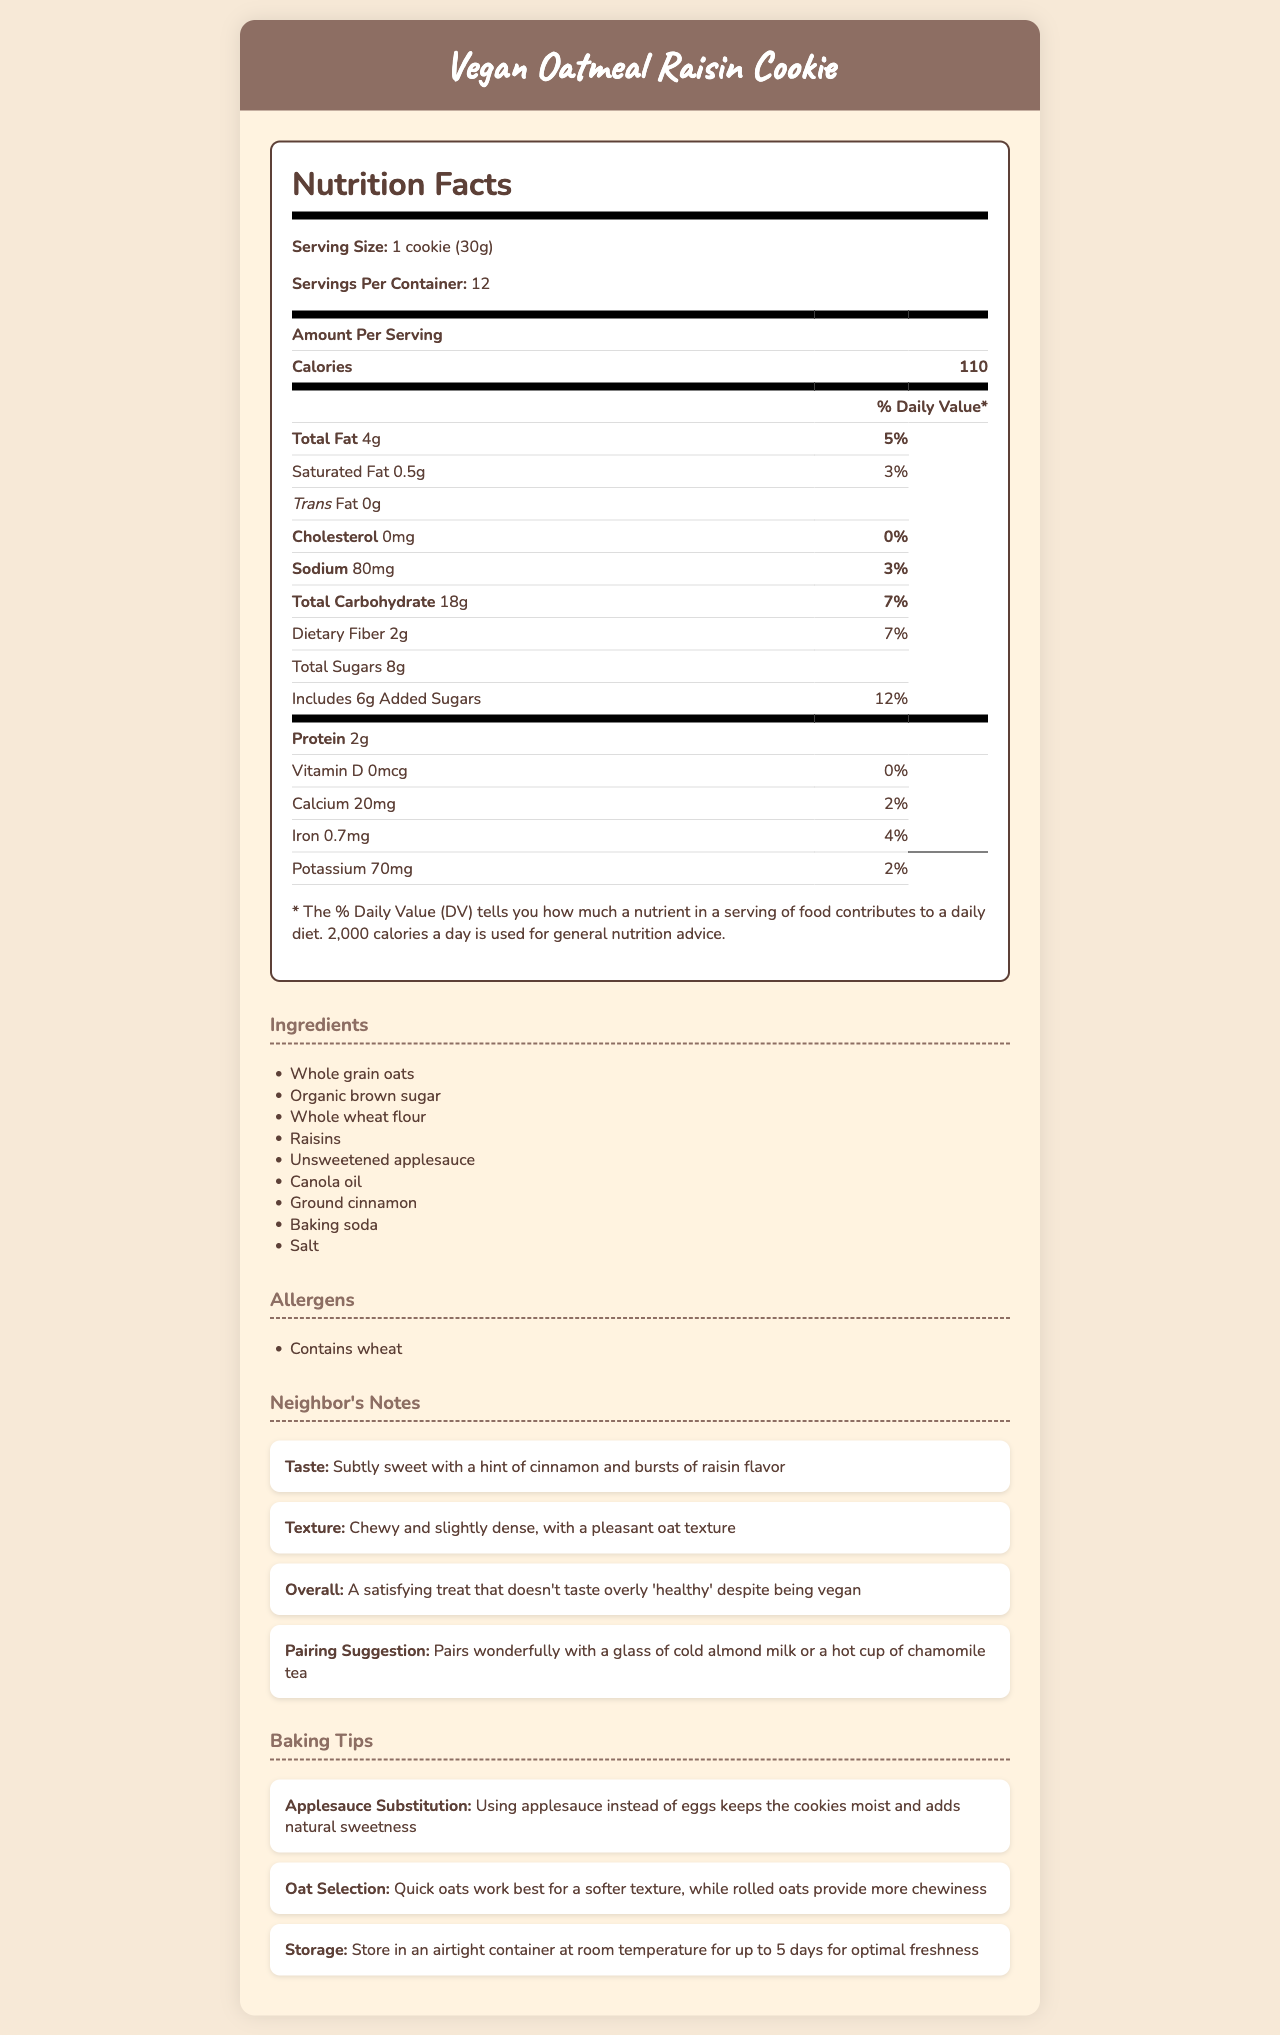what is the serving size of the vegan oatmeal raisin cookie? The serving size is specified at the beginning of the Nutrition Facts section as "1 cookie (30g)".
Answer: 1 cookie (30g) how many calories does one cookie have? The number of calories per serving is indicated in the Amount Per Serving section as "Calories: 110".
Answer: 110 how much total fat is in one serving of the cookie? Under the Total Fat section of the Nutrition Facts, it says "Total Fat 4g".
Answer: 4g what is the daily value percentage for dietary fiber? The daily value percentage for dietary fiber is listed as "7%" in the Total Carbohydrate section of the Nutrition Facts.
Answer: 7% what are the main ingredients of the cookie? The ingredients section lists all the main ingredients used in the cookie.
Answer: Whole grain oats, Organic brown sugar, Whole wheat flour, Raisins, Unsweetened applesauce, Canola oil, Ground cinnamon, Baking soda, Salt what allergens are in this cookie? The allergens section clearly mentions "Contains wheat".
Answer: Contains wheat what is the main advantage of using applesauce instead of eggs? The baking tips mention that using applesauce as a substitute keeps the cookies moist and adds natural sweetness.
Answer: Keeps the cookies moist and adds natural sweetness how many servings per container? The servings per container are mentioned at the beginning of the Nutrition Facts as "Servings Per Container: 12".
Answer: 12 which ingredient provides the cinnamon flavor in the cookie? The ingredient responsible for the cinnamon flavor is ground cinnamon, as listed in the Ingredients section.
Answer: Ground cinnamon what is the overall impression of the cookie according to the neighbor's notes? The Neighbor's Notes section gives an overall impression of the cookie as "A satisfying treat that doesn't taste overly 'healthy' despite being vegan".
Answer: A satisfying treat that doesn't taste overly 'healthy' despite being vegan what does the document say the cookies pair well with? A. Coffee B. Almond milk C. Orange juice D. Water The Neighbor's Notes section suggests that the cookies pair wonderfully with a glass of cold almond milk.
Answer: B. Almond milk how much saturated fat is in a serving of the cookie? A. 0.5g B. 1g C. 2g D. 3g The amount of saturated fat per serving is specified as "0.5g" in the Nutrition Facts section.
Answer: A. 0.5g is there any cholesterol in the cookie? The Nutrition Facts section lists cholesterol as "0mg", indicating there is no cholesterol in the cookie.
Answer: No summarize the main idea of the document. The summary covers the main sections and highlights the purpose and content of the document.
Answer: The document provides the nutrition facts for a vegan oatmeal raisin cookie that uses applesauce as an egg substitute. It offers detailed nutritional information, lists the ingredients and allergens, includes tasting notes and pairing suggestions from a neighbor, and provides baking tips for using applesauce and selecting oats. how many grams of protein are in one cookie? The protein content per serving is listed as "2g" in the Nutrition Facts section.
Answer: 2g what does the document say about the storage of the cookies? The baking tips section advises storing the cookies in an airtight container at room temperature for up to 5 days.
Answer: Store in an airtight container at room temperature for up to 5 days for optimal freshness how many milligrams of potassium are in one cookie? The potassium content per serving is specified as "70mg" in the Nutrition Facts section.
Answer: 70mg what specific type of oats provides more chewiness in the cookie? The baking tips mention that rolled oats provide more chewiness to the cookie.
Answer: Rolled oats how many grams of added sugars are there in one cookie? According to the Nutrition Facts, the amount of added sugars is listed as "6g".
Answer: 6g what is the sodium content in one cookie? A. 50mg B. 60mg C. 70mg D. 80mg The sodium content per serving is indicated as "80mg" in the Nutrition Facts section.
Answer: D. 80mg how many vitamins are in the cookie? The document only specifies the amount of Vitamin D (0mcg, 0%) and makes no mention of other vitamins.
Answer: Not enough information 